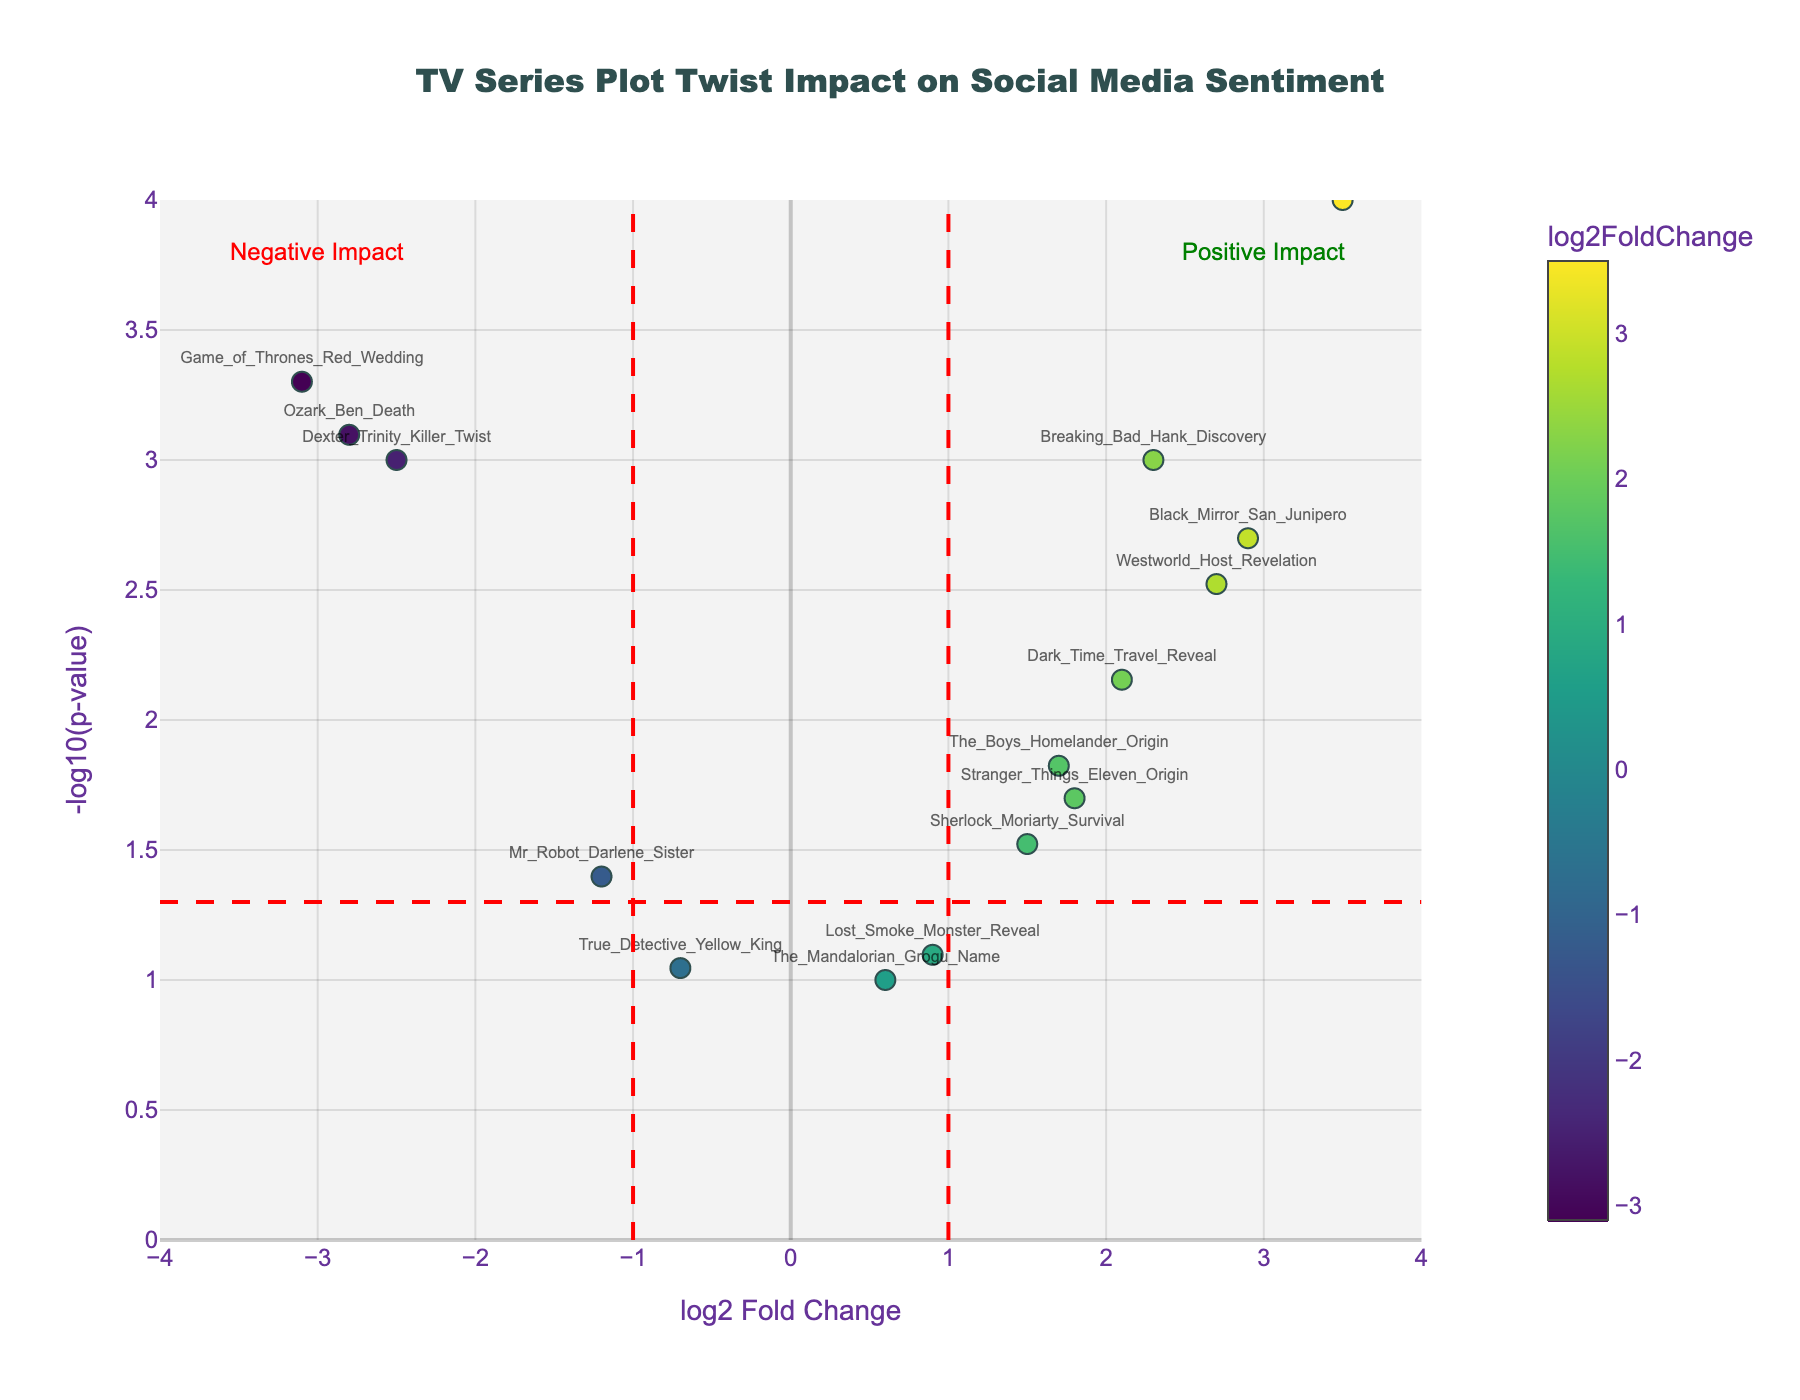What's the title of the plot? The title is typically displayed at the top of the figure, centered and in a larger font size compared to other text elements. Here, it says "TV Series Plot Twist Impact on Social Media Sentiment."
Answer: TV Series Plot Twist Impact on Social Media Sentiment How many plot twists have a positive impact on social media sentiment? Plot twists with a positive impact have a log2FoldChange greater than 0. By counting the data points with positive log2FoldChange values, we identify a total of 9 points.
Answer: 9 Which plot twist has the most significant negative impact? By identifying the data point with the lowest log2FoldChange and the highest -log10(pvalue) within the negative region, we find that "Game_of_Thrones_Red_Wedding" has the most significant negative impact, with a log2FoldChange of -3.1 and a p-value of 0.0005.
Answer: Game_of_Thrones_Red_Wedding What's the log2 Fold Change value of "The_Good_Place_Afterlife_Twist"? Locate the data point labeled "The_Good_Place_Afterlife_Twist" on the plot, then read off the log2FoldChange value. It corresponds to 3.5.
Answer: 3.5 How many plot twists have p-values below 0.01? Plot twists with p-values below 0.01 can be identified by considering those with a y-value (representing -log10(pvalue)) greater than 2. Counting these points, we identify 7 plot twists.
Answer: 7 Which plot twist has the highest -log10(p-value)? The highest -log10(p-value) corresponds to the data point located at the highest y-axis position. This point is "The_Good_Place_Afterlife_Twist," with a value of approximately 4.
Answer: The_Good_Place_Afterlife_Twist Which plot twist lies closest to the origin (0, 0)? The data point closest to the origin has the smallest absolute values for both log2FoldChange and -log10(pvalue). "The_Mandalorian_Grogu_Name" has log2FoldChange of 0.6 and -log10(pvalue) of 0.1, making it the nearest.
Answer: The_Mandalorian_Grogu_Name How does the sentiment impact of "Dexter_Trinity_Killer_Twist" compare to "Ozark_Ben_Death"? Locate both plot twists and compare their log2FoldChange and -log10(pvalue). "Dexter_Trinity_Killer_Twist" (-2.5, 3.0) has a slightly less negative log2FoldChange but a marginal difference in significance compared to "Ozark_Ben_Death" (-2.8, 3.1).
Answer: "Dexter_Trinity_Killer_Twist" has a slightly less negative impact than "Ozark_Ben_Death" What's the interpretation of the red dashed lines in the plot? The vertical red dashed lines at log2FoldChange of -1 and 1 separate significant positive and negative impacts. The horizontal red dashed line at -log10(pvalue) of 1.3 represents a p-value threshold of 0.05 for significance. Data points outside these regions indicate substantial changes in sentiment.
Answer: They indicate significance thresholds for log2FoldChange and p-value 